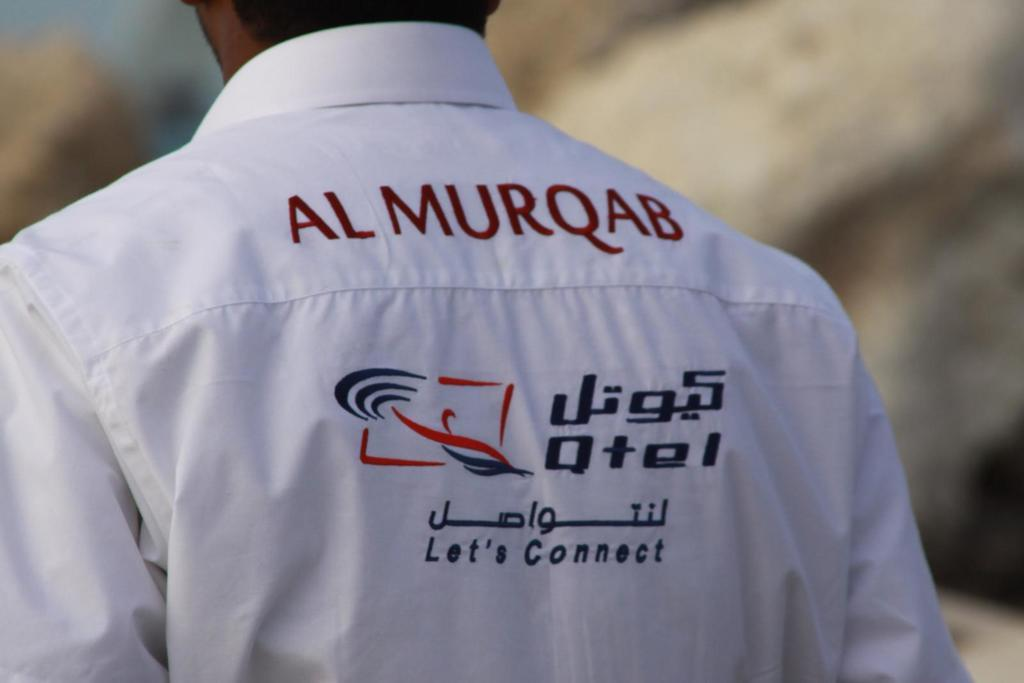<image>
Write a terse but informative summary of the picture. Al Murqab is on the back of a white shirt. 